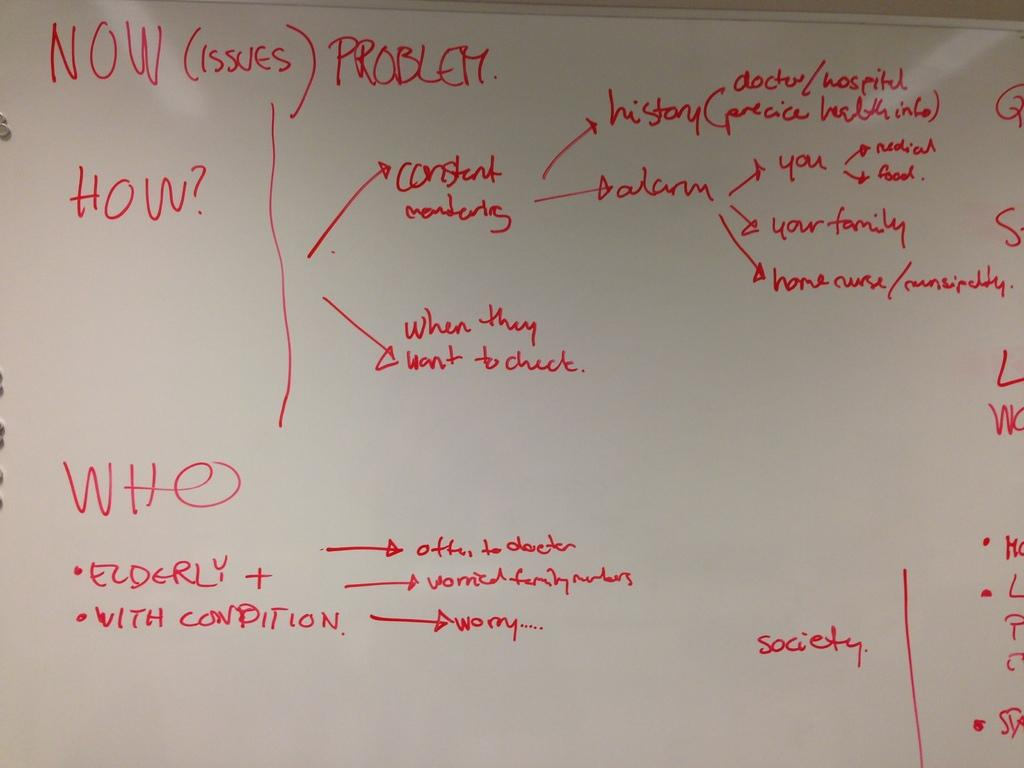Provide a one-sentence caption for the provided image. A white board with writing that says Now (issues) Problems and says how and who on it with explanations. 